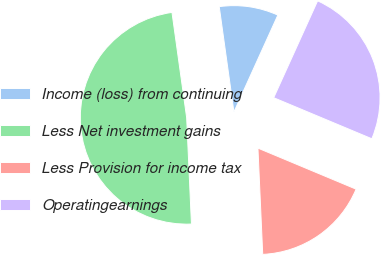<chart> <loc_0><loc_0><loc_500><loc_500><pie_chart><fcel>Income (loss) from continuing<fcel>Less Net investment gains<fcel>Less Provision for income tax<fcel>Operatingearnings<nl><fcel>8.98%<fcel>48.51%<fcel>17.98%<fcel>24.53%<nl></chart> 